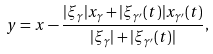<formula> <loc_0><loc_0><loc_500><loc_500>y = x - \frac { | \xi _ { \gamma } | x _ { \gamma } + | \xi _ { \gamma ^ { \prime } } ( t ) | x _ { \gamma ^ { \prime } } ( t ) } { | \xi _ { \gamma } | + | \xi _ { \gamma ^ { \prime } } ( t ) | } ,</formula> 